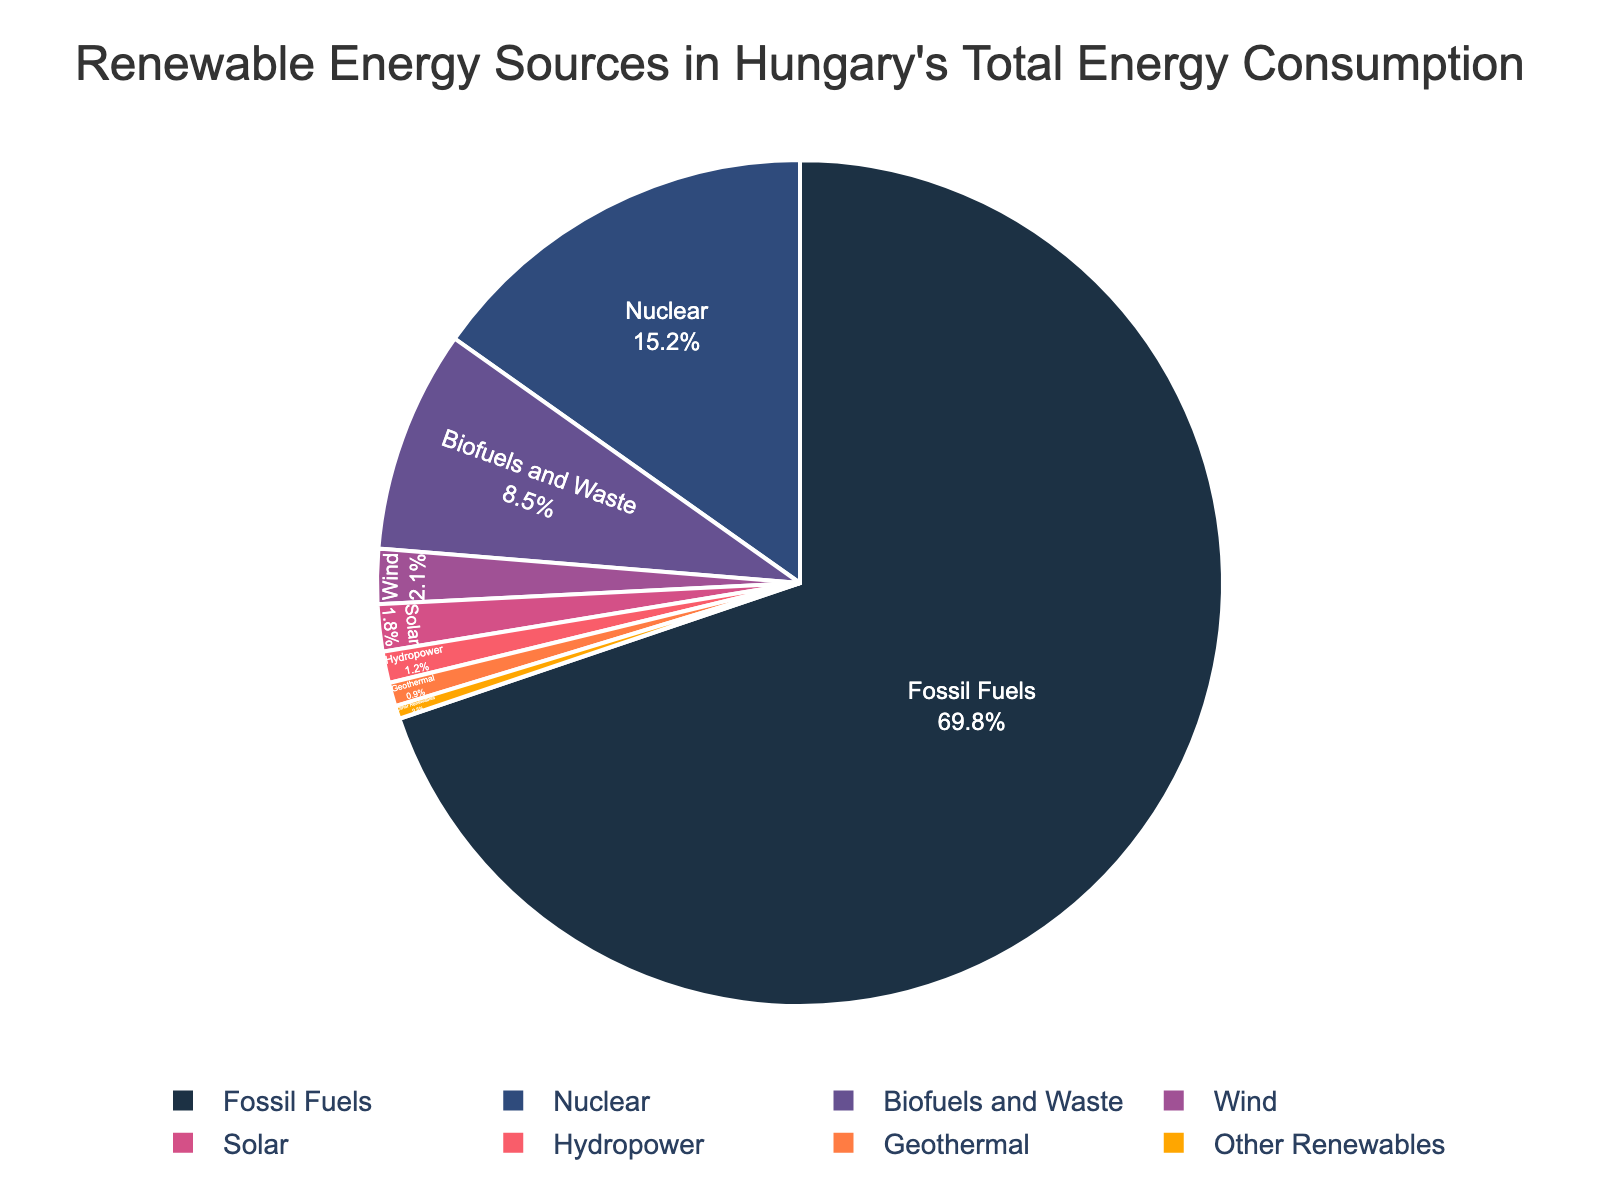Which energy source has the largest share in Hungary's total energy consumption? The largest share corresponds to the sector with the highest percentage value in the figure, which is Fossil Fuels at 69.8%.
Answer: Fossil Fuels What is the combined percentage of renewable energy sources in Hungary's total energy consumption? Sum the percentages of all renewable sources: Biofuels and Waste (8.5) + Wind (2.1) + Solar (1.8) + Hydropower (1.2) + Geothermal (0.9) + Other Renewables (0.5) = 15.0%.
Answer: 15.0% How does the percentage of Nuclear energy compare to that of Biofuels and Waste? Compare the two percentages from the figure: Nuclear is 15.2%, and Biofuels and Waste is 8.5%, so Nuclear is greater.
Answer: Nuclear is greater Which renewable energy source has the smallest share in Hungary's total energy consumption? Identify the renewable source with the lowest percentage: Other Renewables at 0.5%.
Answer: Other Renewables What is the difference in percentage between Fossil Fuels and Nuclear energy? Subtract the percentage of Nuclear from that of Fossil Fuels: 69.8% - 15.2% = 54.6%.
Answer: 54.6% Is the combined percentage of Solar and Wind energy greater than the percentage of Biofuels and Waste? Sum the percentages of Solar and Wind and compare to Biofuels and Waste: Solar (1.8%) + Wind (2.1%) = 3.9%, which is less than Biofuels and Waste (8.5%).
Answer: No What proportion of the total energy consumption do non-renewable sources (Fossil Fuels and Nuclear) account for? Add the percentages of Fossil Fuels and Nuclear: Fossil Fuels (69.8%) + Nuclear (15.2%) = 85.0%.
Answer: 85.0% Which renewable energy source is closest in percentage to Hydropower? Compare the percentages: Hydropower (1.2%), the closest is Solar (1.8%).
Answer: Solar If the percentage of Fossil Fuels was reduced by 10%, what would be the new percentage? Subtract 10% from 69.8%: 69.8% - 10% = 59.8%.
Answer: 59.8% Is the percentage of Wind energy more than double that of Geothermal energy? Compare Wind (2.1%) to twice the Geothermal percentage: 2 * 0.9% = 1.8%. Since 2.1% > 1.8%, Wind is more.
Answer: Yes 